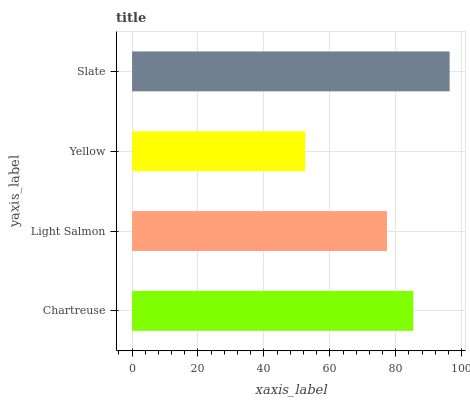Is Yellow the minimum?
Answer yes or no. Yes. Is Slate the maximum?
Answer yes or no. Yes. Is Light Salmon the minimum?
Answer yes or no. No. Is Light Salmon the maximum?
Answer yes or no. No. Is Chartreuse greater than Light Salmon?
Answer yes or no. Yes. Is Light Salmon less than Chartreuse?
Answer yes or no. Yes. Is Light Salmon greater than Chartreuse?
Answer yes or no. No. Is Chartreuse less than Light Salmon?
Answer yes or no. No. Is Chartreuse the high median?
Answer yes or no. Yes. Is Light Salmon the low median?
Answer yes or no. Yes. Is Slate the high median?
Answer yes or no. No. Is Slate the low median?
Answer yes or no. No. 